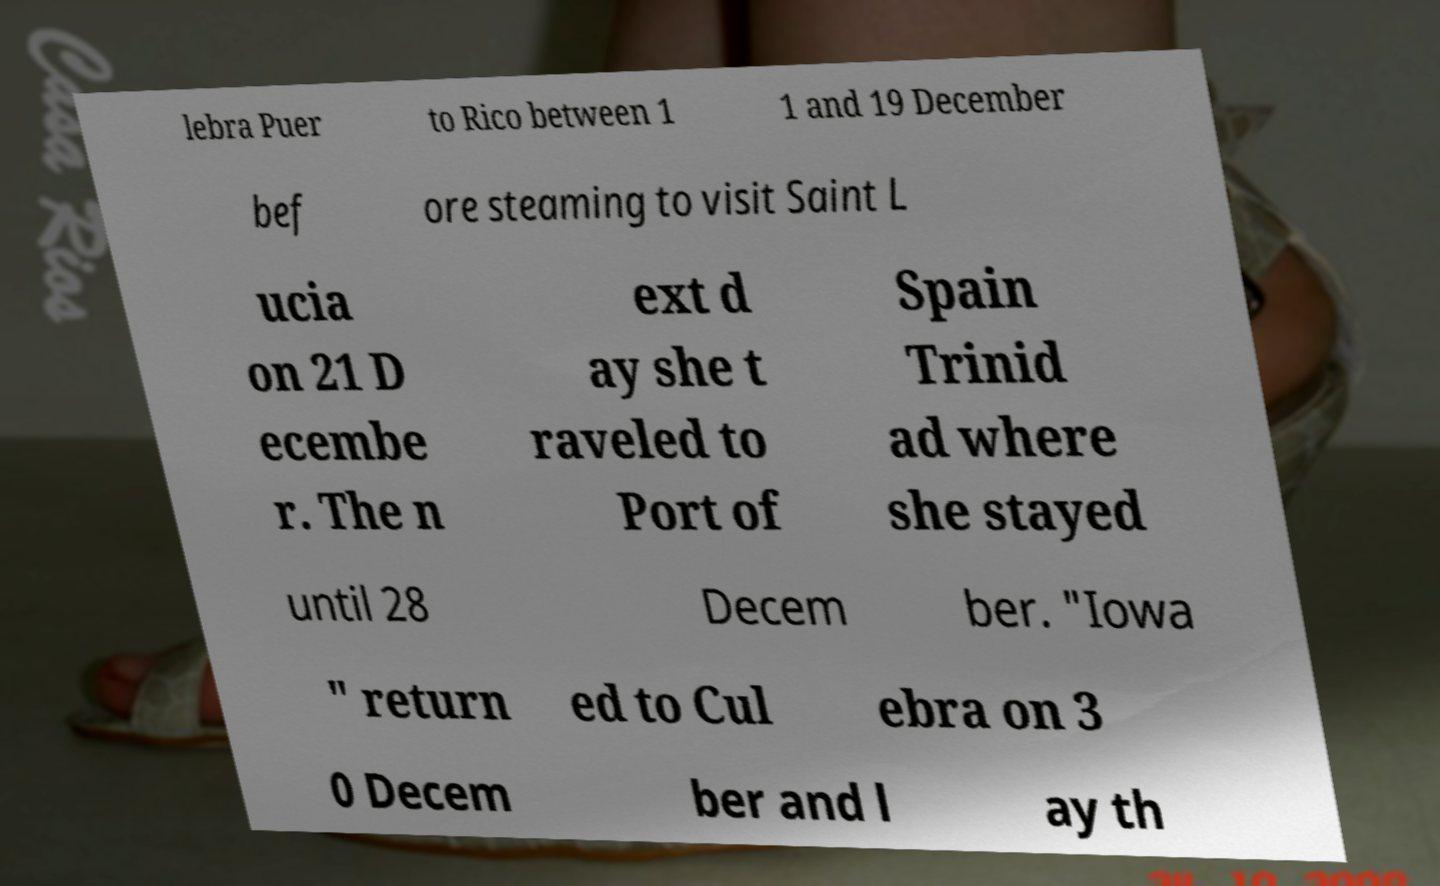Please identify and transcribe the text found in this image. lebra Puer to Rico between 1 1 and 19 December bef ore steaming to visit Saint L ucia on 21 D ecembe r. The n ext d ay she t raveled to Port of Spain Trinid ad where she stayed until 28 Decem ber. "Iowa " return ed to Cul ebra on 3 0 Decem ber and l ay th 